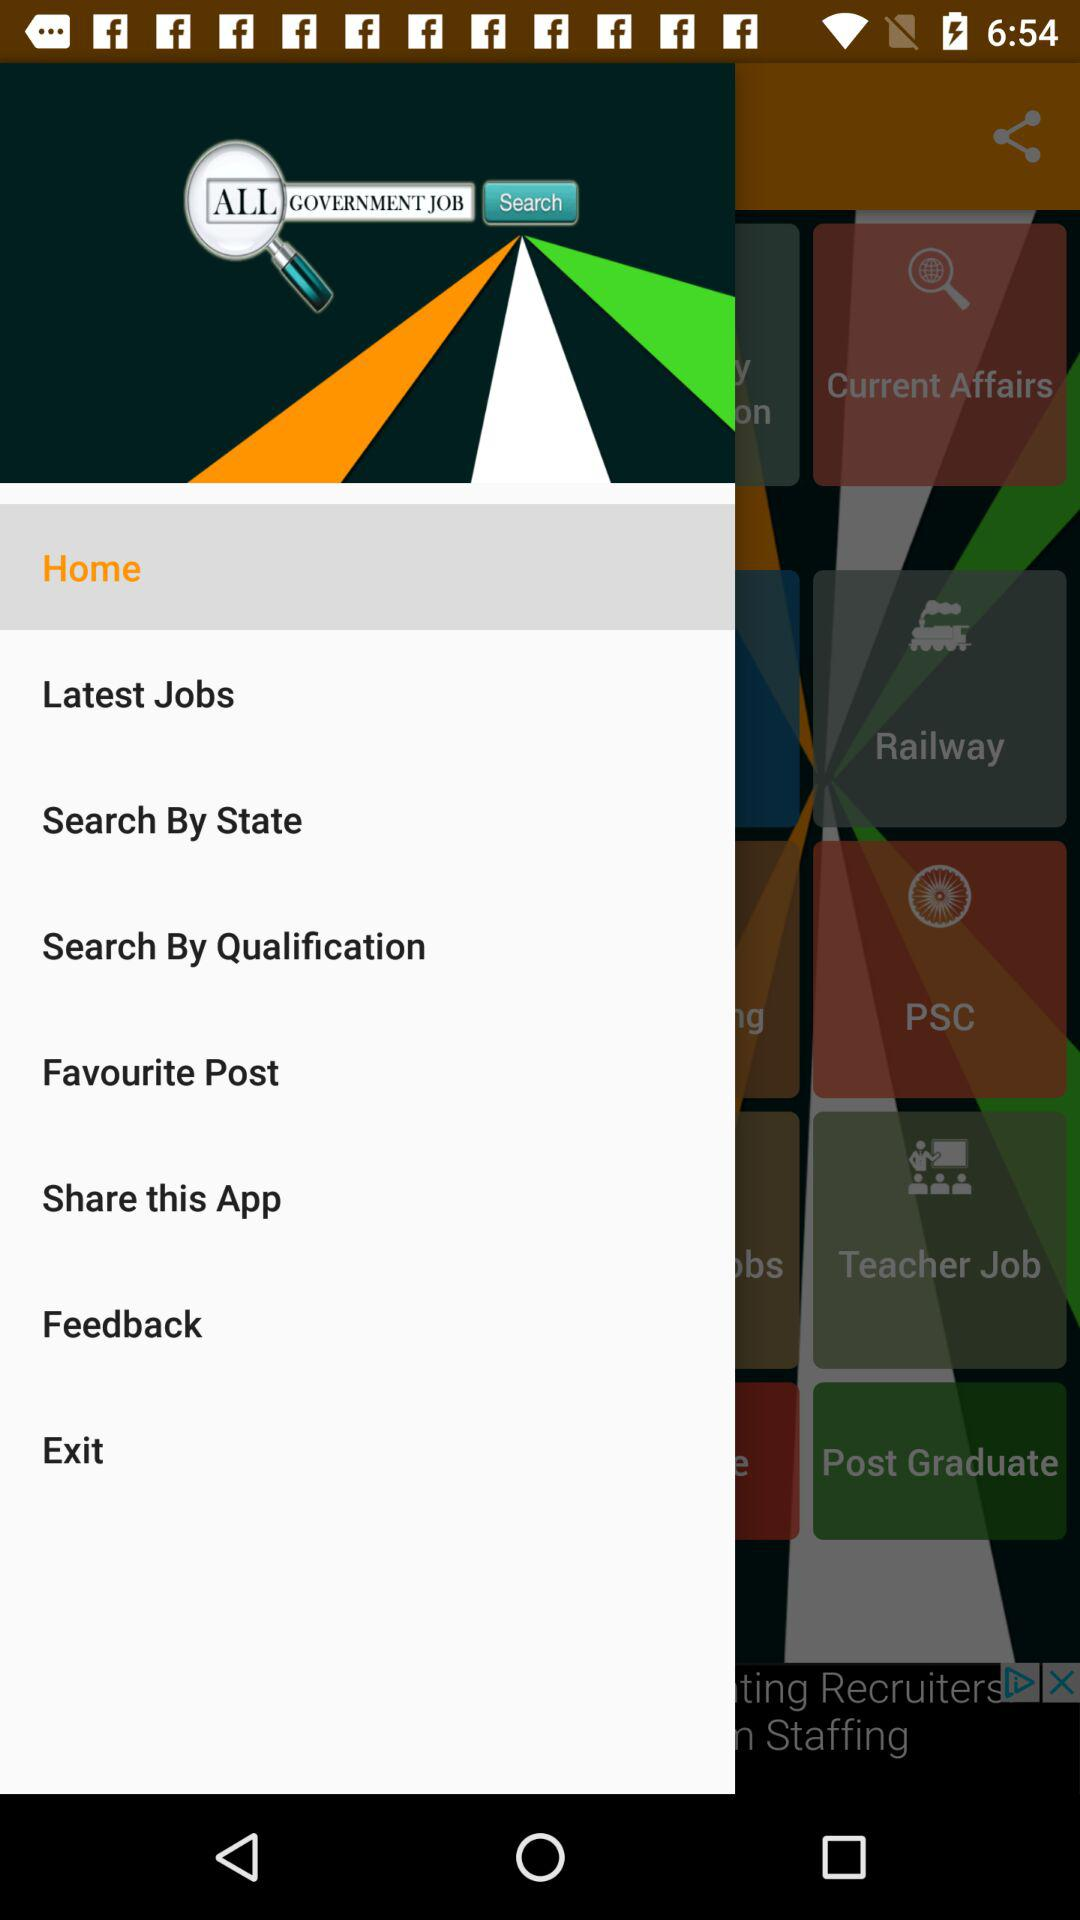What is the name of the application? The name of the application is "ALL GOVERNMENT JOB". 